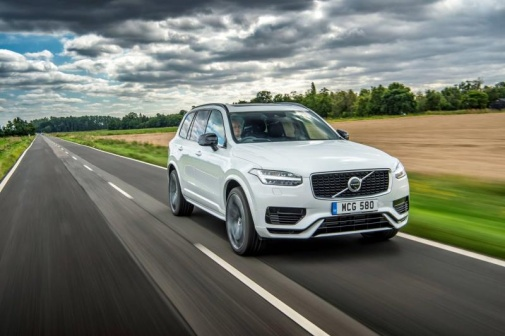Where do you think this road leads? This rural highway likely meanders through the scenic countryside, connecting small towns and villages. It might lead to picturesque landscapes, farmlands, or a charming little town hidden beyond the horizon. The drive promises constant companionship of nature, with fields and trees gracing either side of the path, offering a tranquil and scenic route. 